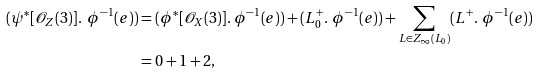<formula> <loc_0><loc_0><loc_500><loc_500>( \psi ^ { * } [ \mathcal { O } _ { Z } ( 3 ) ] . \ \phi ^ { - 1 } ( e ) ) & = ( \phi ^ { * } [ \mathcal { O } _ { X } ( 3 ) ] . \ \phi ^ { - 1 } ( e ) ) + ( L _ { 0 } ^ { + } . \ \phi ^ { - 1 } ( e ) ) + \sum _ { L \in { Z _ { \infty } ( L _ { 0 } ) } } ( L ^ { + } . \ \phi ^ { - 1 } ( e ) ) \\ & = 0 + 1 + 2 ,</formula> 